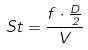Convert formula to latex. <formula><loc_0><loc_0><loc_500><loc_500>S t = \frac { f \cdot \frac { D } { 2 } } { V }</formula> 